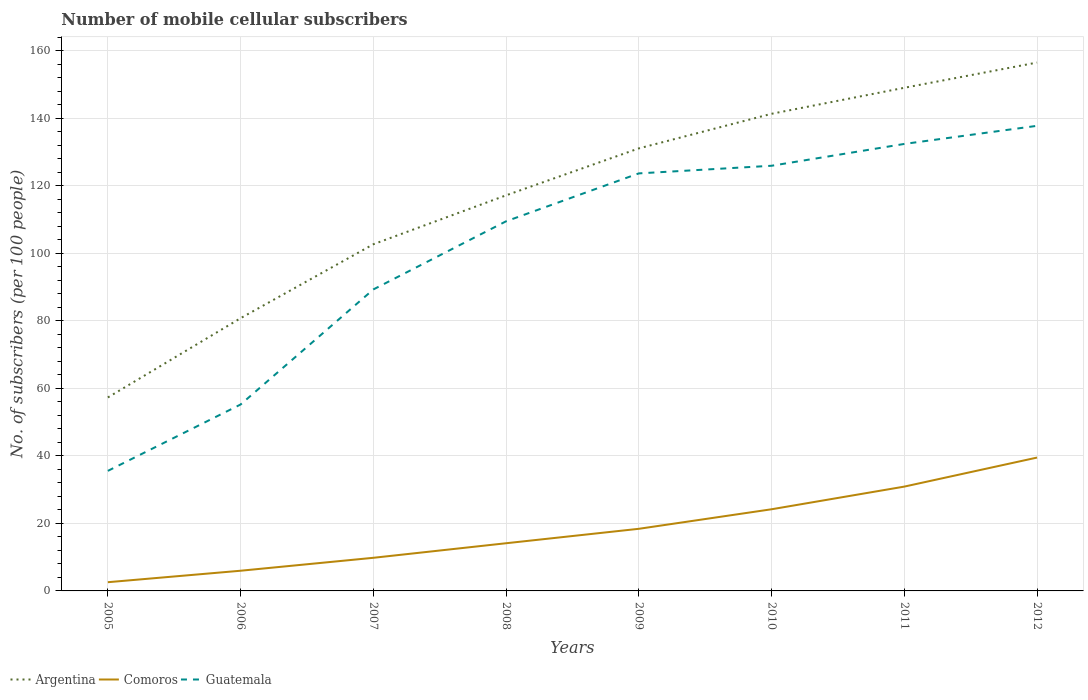Across all years, what is the maximum number of mobile cellular subscribers in Comoros?
Keep it short and to the point. 2.58. What is the total number of mobile cellular subscribers in Comoros in the graph?
Your response must be concise. -16.78. What is the difference between the highest and the second highest number of mobile cellular subscribers in Guatemala?
Keep it short and to the point. 102.25. What is the difference between the highest and the lowest number of mobile cellular subscribers in Guatemala?
Offer a terse response. 5. How many lines are there?
Your response must be concise. 3. How many years are there in the graph?
Offer a very short reply. 8. What is the difference between two consecutive major ticks on the Y-axis?
Provide a succinct answer. 20. Are the values on the major ticks of Y-axis written in scientific E-notation?
Keep it short and to the point. No. Where does the legend appear in the graph?
Offer a very short reply. Bottom left. What is the title of the graph?
Give a very brief answer. Number of mobile cellular subscribers. Does "Venezuela" appear as one of the legend labels in the graph?
Your response must be concise. No. What is the label or title of the X-axis?
Make the answer very short. Years. What is the label or title of the Y-axis?
Ensure brevity in your answer.  No. of subscribers (per 100 people). What is the No. of subscribers (per 100 people) of Argentina in 2005?
Keep it short and to the point. 57.33. What is the No. of subscribers (per 100 people) in Comoros in 2005?
Offer a terse response. 2.58. What is the No. of subscribers (per 100 people) of Guatemala in 2005?
Your answer should be compact. 35.57. What is the No. of subscribers (per 100 people) of Argentina in 2006?
Provide a short and direct response. 80.82. What is the No. of subscribers (per 100 people) in Comoros in 2006?
Provide a short and direct response. 5.98. What is the No. of subscribers (per 100 people) of Guatemala in 2006?
Provide a short and direct response. 55.24. What is the No. of subscribers (per 100 people) in Argentina in 2007?
Provide a short and direct response. 102.72. What is the No. of subscribers (per 100 people) of Comoros in 2007?
Give a very brief answer. 9.82. What is the No. of subscribers (per 100 people) in Guatemala in 2007?
Give a very brief answer. 89.33. What is the No. of subscribers (per 100 people) in Argentina in 2008?
Your answer should be compact. 117.22. What is the No. of subscribers (per 100 people) in Comoros in 2008?
Your answer should be very brief. 14.13. What is the No. of subscribers (per 100 people) in Guatemala in 2008?
Keep it short and to the point. 109.53. What is the No. of subscribers (per 100 people) of Argentina in 2009?
Offer a very short reply. 131.13. What is the No. of subscribers (per 100 people) of Comoros in 2009?
Offer a very short reply. 18.41. What is the No. of subscribers (per 100 people) of Guatemala in 2009?
Offer a terse response. 123.72. What is the No. of subscribers (per 100 people) in Argentina in 2010?
Keep it short and to the point. 141.38. What is the No. of subscribers (per 100 people) of Comoros in 2010?
Give a very brief answer. 24.2. What is the No. of subscribers (per 100 people) of Guatemala in 2010?
Ensure brevity in your answer.  125.98. What is the No. of subscribers (per 100 people) of Argentina in 2011?
Provide a short and direct response. 149.09. What is the No. of subscribers (per 100 people) in Comoros in 2011?
Offer a terse response. 30.91. What is the No. of subscribers (per 100 people) of Guatemala in 2011?
Provide a succinct answer. 132.45. What is the No. of subscribers (per 100 people) in Argentina in 2012?
Your answer should be very brief. 156.56. What is the No. of subscribers (per 100 people) of Comoros in 2012?
Provide a short and direct response. 39.51. What is the No. of subscribers (per 100 people) of Guatemala in 2012?
Make the answer very short. 137.82. Across all years, what is the maximum No. of subscribers (per 100 people) in Argentina?
Make the answer very short. 156.56. Across all years, what is the maximum No. of subscribers (per 100 people) in Comoros?
Your answer should be very brief. 39.51. Across all years, what is the maximum No. of subscribers (per 100 people) in Guatemala?
Provide a short and direct response. 137.82. Across all years, what is the minimum No. of subscribers (per 100 people) in Argentina?
Your answer should be very brief. 57.33. Across all years, what is the minimum No. of subscribers (per 100 people) of Comoros?
Provide a short and direct response. 2.58. Across all years, what is the minimum No. of subscribers (per 100 people) of Guatemala?
Ensure brevity in your answer.  35.57. What is the total No. of subscribers (per 100 people) in Argentina in the graph?
Give a very brief answer. 936.26. What is the total No. of subscribers (per 100 people) in Comoros in the graph?
Ensure brevity in your answer.  145.53. What is the total No. of subscribers (per 100 people) in Guatemala in the graph?
Your response must be concise. 809.65. What is the difference between the No. of subscribers (per 100 people) of Argentina in 2005 and that in 2006?
Make the answer very short. -23.49. What is the difference between the No. of subscribers (per 100 people) of Comoros in 2005 and that in 2006?
Your answer should be compact. -3.4. What is the difference between the No. of subscribers (per 100 people) of Guatemala in 2005 and that in 2006?
Your answer should be compact. -19.67. What is the difference between the No. of subscribers (per 100 people) in Argentina in 2005 and that in 2007?
Offer a terse response. -45.39. What is the difference between the No. of subscribers (per 100 people) of Comoros in 2005 and that in 2007?
Give a very brief answer. -7.23. What is the difference between the No. of subscribers (per 100 people) in Guatemala in 2005 and that in 2007?
Provide a short and direct response. -53.76. What is the difference between the No. of subscribers (per 100 people) of Argentina in 2005 and that in 2008?
Your answer should be compact. -59.89. What is the difference between the No. of subscribers (per 100 people) in Comoros in 2005 and that in 2008?
Give a very brief answer. -11.55. What is the difference between the No. of subscribers (per 100 people) in Guatemala in 2005 and that in 2008?
Ensure brevity in your answer.  -73.96. What is the difference between the No. of subscribers (per 100 people) in Argentina in 2005 and that in 2009?
Your response must be concise. -73.8. What is the difference between the No. of subscribers (per 100 people) of Comoros in 2005 and that in 2009?
Your answer should be very brief. -15.82. What is the difference between the No. of subscribers (per 100 people) of Guatemala in 2005 and that in 2009?
Make the answer very short. -88.15. What is the difference between the No. of subscribers (per 100 people) of Argentina in 2005 and that in 2010?
Your response must be concise. -84.05. What is the difference between the No. of subscribers (per 100 people) of Comoros in 2005 and that in 2010?
Give a very brief answer. -21.61. What is the difference between the No. of subscribers (per 100 people) of Guatemala in 2005 and that in 2010?
Your answer should be very brief. -90.41. What is the difference between the No. of subscribers (per 100 people) in Argentina in 2005 and that in 2011?
Give a very brief answer. -91.76. What is the difference between the No. of subscribers (per 100 people) of Comoros in 2005 and that in 2011?
Your answer should be compact. -28.33. What is the difference between the No. of subscribers (per 100 people) in Guatemala in 2005 and that in 2011?
Give a very brief answer. -96.88. What is the difference between the No. of subscribers (per 100 people) of Argentina in 2005 and that in 2012?
Your response must be concise. -99.24. What is the difference between the No. of subscribers (per 100 people) of Comoros in 2005 and that in 2012?
Your answer should be compact. -36.93. What is the difference between the No. of subscribers (per 100 people) of Guatemala in 2005 and that in 2012?
Give a very brief answer. -102.25. What is the difference between the No. of subscribers (per 100 people) of Argentina in 2006 and that in 2007?
Provide a short and direct response. -21.9. What is the difference between the No. of subscribers (per 100 people) of Comoros in 2006 and that in 2007?
Make the answer very short. -3.83. What is the difference between the No. of subscribers (per 100 people) of Guatemala in 2006 and that in 2007?
Your answer should be very brief. -34.09. What is the difference between the No. of subscribers (per 100 people) in Argentina in 2006 and that in 2008?
Offer a very short reply. -36.4. What is the difference between the No. of subscribers (per 100 people) of Comoros in 2006 and that in 2008?
Your response must be concise. -8.15. What is the difference between the No. of subscribers (per 100 people) in Guatemala in 2006 and that in 2008?
Your answer should be compact. -54.29. What is the difference between the No. of subscribers (per 100 people) in Argentina in 2006 and that in 2009?
Make the answer very short. -50.31. What is the difference between the No. of subscribers (per 100 people) of Comoros in 2006 and that in 2009?
Provide a short and direct response. -12.42. What is the difference between the No. of subscribers (per 100 people) in Guatemala in 2006 and that in 2009?
Provide a short and direct response. -68.48. What is the difference between the No. of subscribers (per 100 people) in Argentina in 2006 and that in 2010?
Give a very brief answer. -60.56. What is the difference between the No. of subscribers (per 100 people) of Comoros in 2006 and that in 2010?
Your response must be concise. -18.21. What is the difference between the No. of subscribers (per 100 people) in Guatemala in 2006 and that in 2010?
Your response must be concise. -70.74. What is the difference between the No. of subscribers (per 100 people) of Argentina in 2006 and that in 2011?
Keep it short and to the point. -68.27. What is the difference between the No. of subscribers (per 100 people) of Comoros in 2006 and that in 2011?
Your answer should be very brief. -24.93. What is the difference between the No. of subscribers (per 100 people) of Guatemala in 2006 and that in 2011?
Your answer should be compact. -77.21. What is the difference between the No. of subscribers (per 100 people) of Argentina in 2006 and that in 2012?
Provide a short and direct response. -75.75. What is the difference between the No. of subscribers (per 100 people) in Comoros in 2006 and that in 2012?
Your answer should be very brief. -33.53. What is the difference between the No. of subscribers (per 100 people) in Guatemala in 2006 and that in 2012?
Keep it short and to the point. -82.58. What is the difference between the No. of subscribers (per 100 people) of Argentina in 2007 and that in 2008?
Offer a very short reply. -14.5. What is the difference between the No. of subscribers (per 100 people) in Comoros in 2007 and that in 2008?
Make the answer very short. -4.31. What is the difference between the No. of subscribers (per 100 people) in Guatemala in 2007 and that in 2008?
Your response must be concise. -20.19. What is the difference between the No. of subscribers (per 100 people) of Argentina in 2007 and that in 2009?
Provide a succinct answer. -28.41. What is the difference between the No. of subscribers (per 100 people) of Comoros in 2007 and that in 2009?
Provide a short and direct response. -8.59. What is the difference between the No. of subscribers (per 100 people) in Guatemala in 2007 and that in 2009?
Your answer should be very brief. -34.39. What is the difference between the No. of subscribers (per 100 people) in Argentina in 2007 and that in 2010?
Make the answer very short. -38.66. What is the difference between the No. of subscribers (per 100 people) in Comoros in 2007 and that in 2010?
Offer a terse response. -14.38. What is the difference between the No. of subscribers (per 100 people) in Guatemala in 2007 and that in 2010?
Your answer should be compact. -36.65. What is the difference between the No. of subscribers (per 100 people) in Argentina in 2007 and that in 2011?
Make the answer very short. -46.37. What is the difference between the No. of subscribers (per 100 people) of Comoros in 2007 and that in 2011?
Offer a terse response. -21.09. What is the difference between the No. of subscribers (per 100 people) of Guatemala in 2007 and that in 2011?
Your response must be concise. -43.12. What is the difference between the No. of subscribers (per 100 people) of Argentina in 2007 and that in 2012?
Ensure brevity in your answer.  -53.84. What is the difference between the No. of subscribers (per 100 people) in Comoros in 2007 and that in 2012?
Offer a terse response. -29.7. What is the difference between the No. of subscribers (per 100 people) in Guatemala in 2007 and that in 2012?
Ensure brevity in your answer.  -48.48. What is the difference between the No. of subscribers (per 100 people) of Argentina in 2008 and that in 2009?
Provide a succinct answer. -13.91. What is the difference between the No. of subscribers (per 100 people) of Comoros in 2008 and that in 2009?
Offer a terse response. -4.28. What is the difference between the No. of subscribers (per 100 people) of Guatemala in 2008 and that in 2009?
Keep it short and to the point. -14.19. What is the difference between the No. of subscribers (per 100 people) in Argentina in 2008 and that in 2010?
Your answer should be very brief. -24.16. What is the difference between the No. of subscribers (per 100 people) of Comoros in 2008 and that in 2010?
Provide a short and direct response. -10.07. What is the difference between the No. of subscribers (per 100 people) in Guatemala in 2008 and that in 2010?
Ensure brevity in your answer.  -16.46. What is the difference between the No. of subscribers (per 100 people) of Argentina in 2008 and that in 2011?
Your answer should be very brief. -31.87. What is the difference between the No. of subscribers (per 100 people) in Comoros in 2008 and that in 2011?
Make the answer very short. -16.78. What is the difference between the No. of subscribers (per 100 people) in Guatemala in 2008 and that in 2011?
Offer a terse response. -22.92. What is the difference between the No. of subscribers (per 100 people) of Argentina in 2008 and that in 2012?
Your answer should be very brief. -39.34. What is the difference between the No. of subscribers (per 100 people) of Comoros in 2008 and that in 2012?
Your answer should be very brief. -25.38. What is the difference between the No. of subscribers (per 100 people) in Guatemala in 2008 and that in 2012?
Give a very brief answer. -28.29. What is the difference between the No. of subscribers (per 100 people) of Argentina in 2009 and that in 2010?
Keep it short and to the point. -10.25. What is the difference between the No. of subscribers (per 100 people) in Comoros in 2009 and that in 2010?
Provide a succinct answer. -5.79. What is the difference between the No. of subscribers (per 100 people) in Guatemala in 2009 and that in 2010?
Your answer should be compact. -2.26. What is the difference between the No. of subscribers (per 100 people) of Argentina in 2009 and that in 2011?
Provide a succinct answer. -17.96. What is the difference between the No. of subscribers (per 100 people) of Comoros in 2009 and that in 2011?
Your answer should be very brief. -12.51. What is the difference between the No. of subscribers (per 100 people) of Guatemala in 2009 and that in 2011?
Offer a very short reply. -8.73. What is the difference between the No. of subscribers (per 100 people) of Argentina in 2009 and that in 2012?
Make the answer very short. -25.44. What is the difference between the No. of subscribers (per 100 people) of Comoros in 2009 and that in 2012?
Provide a succinct answer. -21.11. What is the difference between the No. of subscribers (per 100 people) of Guatemala in 2009 and that in 2012?
Your answer should be compact. -14.1. What is the difference between the No. of subscribers (per 100 people) in Argentina in 2010 and that in 2011?
Your response must be concise. -7.71. What is the difference between the No. of subscribers (per 100 people) in Comoros in 2010 and that in 2011?
Provide a short and direct response. -6.71. What is the difference between the No. of subscribers (per 100 people) of Guatemala in 2010 and that in 2011?
Provide a short and direct response. -6.47. What is the difference between the No. of subscribers (per 100 people) in Argentina in 2010 and that in 2012?
Provide a short and direct response. -15.18. What is the difference between the No. of subscribers (per 100 people) of Comoros in 2010 and that in 2012?
Your answer should be very brief. -15.32. What is the difference between the No. of subscribers (per 100 people) of Guatemala in 2010 and that in 2012?
Ensure brevity in your answer.  -11.84. What is the difference between the No. of subscribers (per 100 people) in Argentina in 2011 and that in 2012?
Provide a short and direct response. -7.47. What is the difference between the No. of subscribers (per 100 people) in Comoros in 2011 and that in 2012?
Your answer should be very brief. -8.6. What is the difference between the No. of subscribers (per 100 people) of Guatemala in 2011 and that in 2012?
Provide a succinct answer. -5.37. What is the difference between the No. of subscribers (per 100 people) of Argentina in 2005 and the No. of subscribers (per 100 people) of Comoros in 2006?
Make the answer very short. 51.35. What is the difference between the No. of subscribers (per 100 people) in Argentina in 2005 and the No. of subscribers (per 100 people) in Guatemala in 2006?
Your response must be concise. 2.09. What is the difference between the No. of subscribers (per 100 people) of Comoros in 2005 and the No. of subscribers (per 100 people) of Guatemala in 2006?
Provide a short and direct response. -52.66. What is the difference between the No. of subscribers (per 100 people) in Argentina in 2005 and the No. of subscribers (per 100 people) in Comoros in 2007?
Offer a very short reply. 47.51. What is the difference between the No. of subscribers (per 100 people) in Argentina in 2005 and the No. of subscribers (per 100 people) in Guatemala in 2007?
Give a very brief answer. -32.01. What is the difference between the No. of subscribers (per 100 people) in Comoros in 2005 and the No. of subscribers (per 100 people) in Guatemala in 2007?
Provide a succinct answer. -86.75. What is the difference between the No. of subscribers (per 100 people) in Argentina in 2005 and the No. of subscribers (per 100 people) in Comoros in 2008?
Provide a succinct answer. 43.2. What is the difference between the No. of subscribers (per 100 people) in Argentina in 2005 and the No. of subscribers (per 100 people) in Guatemala in 2008?
Offer a terse response. -52.2. What is the difference between the No. of subscribers (per 100 people) of Comoros in 2005 and the No. of subscribers (per 100 people) of Guatemala in 2008?
Your answer should be compact. -106.94. What is the difference between the No. of subscribers (per 100 people) of Argentina in 2005 and the No. of subscribers (per 100 people) of Comoros in 2009?
Make the answer very short. 38.92. What is the difference between the No. of subscribers (per 100 people) in Argentina in 2005 and the No. of subscribers (per 100 people) in Guatemala in 2009?
Provide a short and direct response. -66.39. What is the difference between the No. of subscribers (per 100 people) in Comoros in 2005 and the No. of subscribers (per 100 people) in Guatemala in 2009?
Provide a succinct answer. -121.14. What is the difference between the No. of subscribers (per 100 people) of Argentina in 2005 and the No. of subscribers (per 100 people) of Comoros in 2010?
Your answer should be compact. 33.13. What is the difference between the No. of subscribers (per 100 people) in Argentina in 2005 and the No. of subscribers (per 100 people) in Guatemala in 2010?
Give a very brief answer. -68.65. What is the difference between the No. of subscribers (per 100 people) in Comoros in 2005 and the No. of subscribers (per 100 people) in Guatemala in 2010?
Provide a short and direct response. -123.4. What is the difference between the No. of subscribers (per 100 people) in Argentina in 2005 and the No. of subscribers (per 100 people) in Comoros in 2011?
Keep it short and to the point. 26.42. What is the difference between the No. of subscribers (per 100 people) of Argentina in 2005 and the No. of subscribers (per 100 people) of Guatemala in 2011?
Your answer should be very brief. -75.12. What is the difference between the No. of subscribers (per 100 people) in Comoros in 2005 and the No. of subscribers (per 100 people) in Guatemala in 2011?
Offer a very short reply. -129.87. What is the difference between the No. of subscribers (per 100 people) of Argentina in 2005 and the No. of subscribers (per 100 people) of Comoros in 2012?
Make the answer very short. 17.82. What is the difference between the No. of subscribers (per 100 people) of Argentina in 2005 and the No. of subscribers (per 100 people) of Guatemala in 2012?
Give a very brief answer. -80.49. What is the difference between the No. of subscribers (per 100 people) of Comoros in 2005 and the No. of subscribers (per 100 people) of Guatemala in 2012?
Provide a succinct answer. -135.24. What is the difference between the No. of subscribers (per 100 people) in Argentina in 2006 and the No. of subscribers (per 100 people) in Comoros in 2007?
Provide a succinct answer. 71. What is the difference between the No. of subscribers (per 100 people) in Argentina in 2006 and the No. of subscribers (per 100 people) in Guatemala in 2007?
Provide a succinct answer. -8.52. What is the difference between the No. of subscribers (per 100 people) of Comoros in 2006 and the No. of subscribers (per 100 people) of Guatemala in 2007?
Your answer should be compact. -83.35. What is the difference between the No. of subscribers (per 100 people) in Argentina in 2006 and the No. of subscribers (per 100 people) in Comoros in 2008?
Make the answer very short. 66.69. What is the difference between the No. of subscribers (per 100 people) of Argentina in 2006 and the No. of subscribers (per 100 people) of Guatemala in 2008?
Provide a short and direct response. -28.71. What is the difference between the No. of subscribers (per 100 people) in Comoros in 2006 and the No. of subscribers (per 100 people) in Guatemala in 2008?
Your response must be concise. -103.55. What is the difference between the No. of subscribers (per 100 people) in Argentina in 2006 and the No. of subscribers (per 100 people) in Comoros in 2009?
Your answer should be very brief. 62.41. What is the difference between the No. of subscribers (per 100 people) in Argentina in 2006 and the No. of subscribers (per 100 people) in Guatemala in 2009?
Provide a short and direct response. -42.9. What is the difference between the No. of subscribers (per 100 people) of Comoros in 2006 and the No. of subscribers (per 100 people) of Guatemala in 2009?
Your response must be concise. -117.74. What is the difference between the No. of subscribers (per 100 people) in Argentina in 2006 and the No. of subscribers (per 100 people) in Comoros in 2010?
Your response must be concise. 56.62. What is the difference between the No. of subscribers (per 100 people) of Argentina in 2006 and the No. of subscribers (per 100 people) of Guatemala in 2010?
Provide a short and direct response. -45.16. What is the difference between the No. of subscribers (per 100 people) of Comoros in 2006 and the No. of subscribers (per 100 people) of Guatemala in 2010?
Ensure brevity in your answer.  -120. What is the difference between the No. of subscribers (per 100 people) of Argentina in 2006 and the No. of subscribers (per 100 people) of Comoros in 2011?
Offer a terse response. 49.91. What is the difference between the No. of subscribers (per 100 people) in Argentina in 2006 and the No. of subscribers (per 100 people) in Guatemala in 2011?
Offer a very short reply. -51.63. What is the difference between the No. of subscribers (per 100 people) in Comoros in 2006 and the No. of subscribers (per 100 people) in Guatemala in 2011?
Offer a very short reply. -126.47. What is the difference between the No. of subscribers (per 100 people) in Argentina in 2006 and the No. of subscribers (per 100 people) in Comoros in 2012?
Offer a terse response. 41.31. What is the difference between the No. of subscribers (per 100 people) of Argentina in 2006 and the No. of subscribers (per 100 people) of Guatemala in 2012?
Provide a succinct answer. -57. What is the difference between the No. of subscribers (per 100 people) of Comoros in 2006 and the No. of subscribers (per 100 people) of Guatemala in 2012?
Keep it short and to the point. -131.84. What is the difference between the No. of subscribers (per 100 people) in Argentina in 2007 and the No. of subscribers (per 100 people) in Comoros in 2008?
Offer a very short reply. 88.59. What is the difference between the No. of subscribers (per 100 people) in Argentina in 2007 and the No. of subscribers (per 100 people) in Guatemala in 2008?
Provide a succinct answer. -6.81. What is the difference between the No. of subscribers (per 100 people) in Comoros in 2007 and the No. of subscribers (per 100 people) in Guatemala in 2008?
Offer a terse response. -99.71. What is the difference between the No. of subscribers (per 100 people) of Argentina in 2007 and the No. of subscribers (per 100 people) of Comoros in 2009?
Keep it short and to the point. 84.32. What is the difference between the No. of subscribers (per 100 people) in Argentina in 2007 and the No. of subscribers (per 100 people) in Guatemala in 2009?
Keep it short and to the point. -21. What is the difference between the No. of subscribers (per 100 people) in Comoros in 2007 and the No. of subscribers (per 100 people) in Guatemala in 2009?
Provide a short and direct response. -113.91. What is the difference between the No. of subscribers (per 100 people) in Argentina in 2007 and the No. of subscribers (per 100 people) in Comoros in 2010?
Ensure brevity in your answer.  78.53. What is the difference between the No. of subscribers (per 100 people) of Argentina in 2007 and the No. of subscribers (per 100 people) of Guatemala in 2010?
Your answer should be compact. -23.26. What is the difference between the No. of subscribers (per 100 people) in Comoros in 2007 and the No. of subscribers (per 100 people) in Guatemala in 2010?
Your response must be concise. -116.17. What is the difference between the No. of subscribers (per 100 people) in Argentina in 2007 and the No. of subscribers (per 100 people) in Comoros in 2011?
Your answer should be very brief. 71.81. What is the difference between the No. of subscribers (per 100 people) in Argentina in 2007 and the No. of subscribers (per 100 people) in Guatemala in 2011?
Keep it short and to the point. -29.73. What is the difference between the No. of subscribers (per 100 people) of Comoros in 2007 and the No. of subscribers (per 100 people) of Guatemala in 2011?
Provide a short and direct response. -122.64. What is the difference between the No. of subscribers (per 100 people) of Argentina in 2007 and the No. of subscribers (per 100 people) of Comoros in 2012?
Your answer should be very brief. 63.21. What is the difference between the No. of subscribers (per 100 people) of Argentina in 2007 and the No. of subscribers (per 100 people) of Guatemala in 2012?
Provide a succinct answer. -35.1. What is the difference between the No. of subscribers (per 100 people) in Comoros in 2007 and the No. of subscribers (per 100 people) in Guatemala in 2012?
Your response must be concise. -128. What is the difference between the No. of subscribers (per 100 people) in Argentina in 2008 and the No. of subscribers (per 100 people) in Comoros in 2009?
Provide a short and direct response. 98.82. What is the difference between the No. of subscribers (per 100 people) of Argentina in 2008 and the No. of subscribers (per 100 people) of Guatemala in 2009?
Give a very brief answer. -6.5. What is the difference between the No. of subscribers (per 100 people) in Comoros in 2008 and the No. of subscribers (per 100 people) in Guatemala in 2009?
Ensure brevity in your answer.  -109.59. What is the difference between the No. of subscribers (per 100 people) in Argentina in 2008 and the No. of subscribers (per 100 people) in Comoros in 2010?
Make the answer very short. 93.03. What is the difference between the No. of subscribers (per 100 people) of Argentina in 2008 and the No. of subscribers (per 100 people) of Guatemala in 2010?
Ensure brevity in your answer.  -8.76. What is the difference between the No. of subscribers (per 100 people) in Comoros in 2008 and the No. of subscribers (per 100 people) in Guatemala in 2010?
Make the answer very short. -111.85. What is the difference between the No. of subscribers (per 100 people) of Argentina in 2008 and the No. of subscribers (per 100 people) of Comoros in 2011?
Keep it short and to the point. 86.31. What is the difference between the No. of subscribers (per 100 people) of Argentina in 2008 and the No. of subscribers (per 100 people) of Guatemala in 2011?
Keep it short and to the point. -15.23. What is the difference between the No. of subscribers (per 100 people) of Comoros in 2008 and the No. of subscribers (per 100 people) of Guatemala in 2011?
Your answer should be compact. -118.32. What is the difference between the No. of subscribers (per 100 people) of Argentina in 2008 and the No. of subscribers (per 100 people) of Comoros in 2012?
Make the answer very short. 77.71. What is the difference between the No. of subscribers (per 100 people) in Argentina in 2008 and the No. of subscribers (per 100 people) in Guatemala in 2012?
Your response must be concise. -20.6. What is the difference between the No. of subscribers (per 100 people) of Comoros in 2008 and the No. of subscribers (per 100 people) of Guatemala in 2012?
Keep it short and to the point. -123.69. What is the difference between the No. of subscribers (per 100 people) in Argentina in 2009 and the No. of subscribers (per 100 people) in Comoros in 2010?
Your response must be concise. 106.93. What is the difference between the No. of subscribers (per 100 people) in Argentina in 2009 and the No. of subscribers (per 100 people) in Guatemala in 2010?
Your response must be concise. 5.15. What is the difference between the No. of subscribers (per 100 people) in Comoros in 2009 and the No. of subscribers (per 100 people) in Guatemala in 2010?
Offer a very short reply. -107.58. What is the difference between the No. of subscribers (per 100 people) of Argentina in 2009 and the No. of subscribers (per 100 people) of Comoros in 2011?
Make the answer very short. 100.22. What is the difference between the No. of subscribers (per 100 people) in Argentina in 2009 and the No. of subscribers (per 100 people) in Guatemala in 2011?
Your answer should be compact. -1.32. What is the difference between the No. of subscribers (per 100 people) in Comoros in 2009 and the No. of subscribers (per 100 people) in Guatemala in 2011?
Provide a short and direct response. -114.05. What is the difference between the No. of subscribers (per 100 people) in Argentina in 2009 and the No. of subscribers (per 100 people) in Comoros in 2012?
Give a very brief answer. 91.62. What is the difference between the No. of subscribers (per 100 people) in Argentina in 2009 and the No. of subscribers (per 100 people) in Guatemala in 2012?
Your response must be concise. -6.69. What is the difference between the No. of subscribers (per 100 people) of Comoros in 2009 and the No. of subscribers (per 100 people) of Guatemala in 2012?
Provide a succinct answer. -119.41. What is the difference between the No. of subscribers (per 100 people) of Argentina in 2010 and the No. of subscribers (per 100 people) of Comoros in 2011?
Your answer should be very brief. 110.47. What is the difference between the No. of subscribers (per 100 people) of Argentina in 2010 and the No. of subscribers (per 100 people) of Guatemala in 2011?
Provide a short and direct response. 8.93. What is the difference between the No. of subscribers (per 100 people) in Comoros in 2010 and the No. of subscribers (per 100 people) in Guatemala in 2011?
Offer a terse response. -108.26. What is the difference between the No. of subscribers (per 100 people) of Argentina in 2010 and the No. of subscribers (per 100 people) of Comoros in 2012?
Offer a terse response. 101.87. What is the difference between the No. of subscribers (per 100 people) of Argentina in 2010 and the No. of subscribers (per 100 people) of Guatemala in 2012?
Give a very brief answer. 3.56. What is the difference between the No. of subscribers (per 100 people) in Comoros in 2010 and the No. of subscribers (per 100 people) in Guatemala in 2012?
Ensure brevity in your answer.  -113.62. What is the difference between the No. of subscribers (per 100 people) in Argentina in 2011 and the No. of subscribers (per 100 people) in Comoros in 2012?
Give a very brief answer. 109.58. What is the difference between the No. of subscribers (per 100 people) in Argentina in 2011 and the No. of subscribers (per 100 people) in Guatemala in 2012?
Your answer should be compact. 11.27. What is the difference between the No. of subscribers (per 100 people) in Comoros in 2011 and the No. of subscribers (per 100 people) in Guatemala in 2012?
Give a very brief answer. -106.91. What is the average No. of subscribers (per 100 people) of Argentina per year?
Keep it short and to the point. 117.03. What is the average No. of subscribers (per 100 people) in Comoros per year?
Provide a short and direct response. 18.19. What is the average No. of subscribers (per 100 people) in Guatemala per year?
Provide a short and direct response. 101.21. In the year 2005, what is the difference between the No. of subscribers (per 100 people) of Argentina and No. of subscribers (per 100 people) of Comoros?
Give a very brief answer. 54.74. In the year 2005, what is the difference between the No. of subscribers (per 100 people) in Argentina and No. of subscribers (per 100 people) in Guatemala?
Provide a succinct answer. 21.76. In the year 2005, what is the difference between the No. of subscribers (per 100 people) in Comoros and No. of subscribers (per 100 people) in Guatemala?
Your response must be concise. -32.99. In the year 2006, what is the difference between the No. of subscribers (per 100 people) of Argentina and No. of subscribers (per 100 people) of Comoros?
Keep it short and to the point. 74.84. In the year 2006, what is the difference between the No. of subscribers (per 100 people) in Argentina and No. of subscribers (per 100 people) in Guatemala?
Make the answer very short. 25.58. In the year 2006, what is the difference between the No. of subscribers (per 100 people) of Comoros and No. of subscribers (per 100 people) of Guatemala?
Provide a short and direct response. -49.26. In the year 2007, what is the difference between the No. of subscribers (per 100 people) of Argentina and No. of subscribers (per 100 people) of Comoros?
Give a very brief answer. 92.91. In the year 2007, what is the difference between the No. of subscribers (per 100 people) in Argentina and No. of subscribers (per 100 people) in Guatemala?
Provide a succinct answer. 13.39. In the year 2007, what is the difference between the No. of subscribers (per 100 people) of Comoros and No. of subscribers (per 100 people) of Guatemala?
Your answer should be compact. -79.52. In the year 2008, what is the difference between the No. of subscribers (per 100 people) of Argentina and No. of subscribers (per 100 people) of Comoros?
Provide a short and direct response. 103.09. In the year 2008, what is the difference between the No. of subscribers (per 100 people) of Argentina and No. of subscribers (per 100 people) of Guatemala?
Ensure brevity in your answer.  7.69. In the year 2008, what is the difference between the No. of subscribers (per 100 people) in Comoros and No. of subscribers (per 100 people) in Guatemala?
Give a very brief answer. -95.4. In the year 2009, what is the difference between the No. of subscribers (per 100 people) in Argentina and No. of subscribers (per 100 people) in Comoros?
Keep it short and to the point. 112.72. In the year 2009, what is the difference between the No. of subscribers (per 100 people) in Argentina and No. of subscribers (per 100 people) in Guatemala?
Your answer should be compact. 7.41. In the year 2009, what is the difference between the No. of subscribers (per 100 people) in Comoros and No. of subscribers (per 100 people) in Guatemala?
Ensure brevity in your answer.  -105.32. In the year 2010, what is the difference between the No. of subscribers (per 100 people) of Argentina and No. of subscribers (per 100 people) of Comoros?
Your answer should be compact. 117.19. In the year 2010, what is the difference between the No. of subscribers (per 100 people) in Argentina and No. of subscribers (per 100 people) in Guatemala?
Your answer should be compact. 15.4. In the year 2010, what is the difference between the No. of subscribers (per 100 people) of Comoros and No. of subscribers (per 100 people) of Guatemala?
Provide a short and direct response. -101.79. In the year 2011, what is the difference between the No. of subscribers (per 100 people) in Argentina and No. of subscribers (per 100 people) in Comoros?
Your answer should be compact. 118.18. In the year 2011, what is the difference between the No. of subscribers (per 100 people) in Argentina and No. of subscribers (per 100 people) in Guatemala?
Offer a terse response. 16.64. In the year 2011, what is the difference between the No. of subscribers (per 100 people) of Comoros and No. of subscribers (per 100 people) of Guatemala?
Keep it short and to the point. -101.54. In the year 2012, what is the difference between the No. of subscribers (per 100 people) of Argentina and No. of subscribers (per 100 people) of Comoros?
Offer a terse response. 117.05. In the year 2012, what is the difference between the No. of subscribers (per 100 people) in Argentina and No. of subscribers (per 100 people) in Guatemala?
Offer a very short reply. 18.75. In the year 2012, what is the difference between the No. of subscribers (per 100 people) of Comoros and No. of subscribers (per 100 people) of Guatemala?
Provide a succinct answer. -98.31. What is the ratio of the No. of subscribers (per 100 people) of Argentina in 2005 to that in 2006?
Offer a terse response. 0.71. What is the ratio of the No. of subscribers (per 100 people) of Comoros in 2005 to that in 2006?
Provide a succinct answer. 0.43. What is the ratio of the No. of subscribers (per 100 people) of Guatemala in 2005 to that in 2006?
Your answer should be very brief. 0.64. What is the ratio of the No. of subscribers (per 100 people) in Argentina in 2005 to that in 2007?
Give a very brief answer. 0.56. What is the ratio of the No. of subscribers (per 100 people) in Comoros in 2005 to that in 2007?
Your response must be concise. 0.26. What is the ratio of the No. of subscribers (per 100 people) in Guatemala in 2005 to that in 2007?
Your answer should be compact. 0.4. What is the ratio of the No. of subscribers (per 100 people) of Argentina in 2005 to that in 2008?
Your answer should be compact. 0.49. What is the ratio of the No. of subscribers (per 100 people) of Comoros in 2005 to that in 2008?
Provide a succinct answer. 0.18. What is the ratio of the No. of subscribers (per 100 people) in Guatemala in 2005 to that in 2008?
Offer a terse response. 0.32. What is the ratio of the No. of subscribers (per 100 people) in Argentina in 2005 to that in 2009?
Offer a very short reply. 0.44. What is the ratio of the No. of subscribers (per 100 people) in Comoros in 2005 to that in 2009?
Your answer should be very brief. 0.14. What is the ratio of the No. of subscribers (per 100 people) of Guatemala in 2005 to that in 2009?
Ensure brevity in your answer.  0.29. What is the ratio of the No. of subscribers (per 100 people) of Argentina in 2005 to that in 2010?
Provide a short and direct response. 0.41. What is the ratio of the No. of subscribers (per 100 people) in Comoros in 2005 to that in 2010?
Provide a succinct answer. 0.11. What is the ratio of the No. of subscribers (per 100 people) of Guatemala in 2005 to that in 2010?
Your response must be concise. 0.28. What is the ratio of the No. of subscribers (per 100 people) of Argentina in 2005 to that in 2011?
Keep it short and to the point. 0.38. What is the ratio of the No. of subscribers (per 100 people) in Comoros in 2005 to that in 2011?
Provide a succinct answer. 0.08. What is the ratio of the No. of subscribers (per 100 people) of Guatemala in 2005 to that in 2011?
Provide a short and direct response. 0.27. What is the ratio of the No. of subscribers (per 100 people) of Argentina in 2005 to that in 2012?
Provide a succinct answer. 0.37. What is the ratio of the No. of subscribers (per 100 people) of Comoros in 2005 to that in 2012?
Provide a succinct answer. 0.07. What is the ratio of the No. of subscribers (per 100 people) of Guatemala in 2005 to that in 2012?
Your answer should be very brief. 0.26. What is the ratio of the No. of subscribers (per 100 people) in Argentina in 2006 to that in 2007?
Offer a terse response. 0.79. What is the ratio of the No. of subscribers (per 100 people) in Comoros in 2006 to that in 2007?
Offer a terse response. 0.61. What is the ratio of the No. of subscribers (per 100 people) in Guatemala in 2006 to that in 2007?
Offer a very short reply. 0.62. What is the ratio of the No. of subscribers (per 100 people) in Argentina in 2006 to that in 2008?
Ensure brevity in your answer.  0.69. What is the ratio of the No. of subscribers (per 100 people) in Comoros in 2006 to that in 2008?
Your answer should be very brief. 0.42. What is the ratio of the No. of subscribers (per 100 people) in Guatemala in 2006 to that in 2008?
Your response must be concise. 0.5. What is the ratio of the No. of subscribers (per 100 people) in Argentina in 2006 to that in 2009?
Offer a terse response. 0.62. What is the ratio of the No. of subscribers (per 100 people) in Comoros in 2006 to that in 2009?
Keep it short and to the point. 0.33. What is the ratio of the No. of subscribers (per 100 people) in Guatemala in 2006 to that in 2009?
Ensure brevity in your answer.  0.45. What is the ratio of the No. of subscribers (per 100 people) in Argentina in 2006 to that in 2010?
Make the answer very short. 0.57. What is the ratio of the No. of subscribers (per 100 people) of Comoros in 2006 to that in 2010?
Offer a terse response. 0.25. What is the ratio of the No. of subscribers (per 100 people) in Guatemala in 2006 to that in 2010?
Offer a terse response. 0.44. What is the ratio of the No. of subscribers (per 100 people) in Argentina in 2006 to that in 2011?
Keep it short and to the point. 0.54. What is the ratio of the No. of subscribers (per 100 people) in Comoros in 2006 to that in 2011?
Your answer should be very brief. 0.19. What is the ratio of the No. of subscribers (per 100 people) in Guatemala in 2006 to that in 2011?
Make the answer very short. 0.42. What is the ratio of the No. of subscribers (per 100 people) in Argentina in 2006 to that in 2012?
Make the answer very short. 0.52. What is the ratio of the No. of subscribers (per 100 people) in Comoros in 2006 to that in 2012?
Ensure brevity in your answer.  0.15. What is the ratio of the No. of subscribers (per 100 people) in Guatemala in 2006 to that in 2012?
Provide a succinct answer. 0.4. What is the ratio of the No. of subscribers (per 100 people) of Argentina in 2007 to that in 2008?
Your response must be concise. 0.88. What is the ratio of the No. of subscribers (per 100 people) of Comoros in 2007 to that in 2008?
Make the answer very short. 0.69. What is the ratio of the No. of subscribers (per 100 people) of Guatemala in 2007 to that in 2008?
Your answer should be very brief. 0.82. What is the ratio of the No. of subscribers (per 100 people) in Argentina in 2007 to that in 2009?
Ensure brevity in your answer.  0.78. What is the ratio of the No. of subscribers (per 100 people) of Comoros in 2007 to that in 2009?
Keep it short and to the point. 0.53. What is the ratio of the No. of subscribers (per 100 people) in Guatemala in 2007 to that in 2009?
Offer a very short reply. 0.72. What is the ratio of the No. of subscribers (per 100 people) in Argentina in 2007 to that in 2010?
Give a very brief answer. 0.73. What is the ratio of the No. of subscribers (per 100 people) in Comoros in 2007 to that in 2010?
Provide a succinct answer. 0.41. What is the ratio of the No. of subscribers (per 100 people) in Guatemala in 2007 to that in 2010?
Provide a succinct answer. 0.71. What is the ratio of the No. of subscribers (per 100 people) of Argentina in 2007 to that in 2011?
Provide a succinct answer. 0.69. What is the ratio of the No. of subscribers (per 100 people) in Comoros in 2007 to that in 2011?
Offer a very short reply. 0.32. What is the ratio of the No. of subscribers (per 100 people) of Guatemala in 2007 to that in 2011?
Your answer should be compact. 0.67. What is the ratio of the No. of subscribers (per 100 people) in Argentina in 2007 to that in 2012?
Provide a short and direct response. 0.66. What is the ratio of the No. of subscribers (per 100 people) in Comoros in 2007 to that in 2012?
Keep it short and to the point. 0.25. What is the ratio of the No. of subscribers (per 100 people) in Guatemala in 2007 to that in 2012?
Offer a very short reply. 0.65. What is the ratio of the No. of subscribers (per 100 people) of Argentina in 2008 to that in 2009?
Keep it short and to the point. 0.89. What is the ratio of the No. of subscribers (per 100 people) in Comoros in 2008 to that in 2009?
Give a very brief answer. 0.77. What is the ratio of the No. of subscribers (per 100 people) of Guatemala in 2008 to that in 2009?
Provide a short and direct response. 0.89. What is the ratio of the No. of subscribers (per 100 people) of Argentina in 2008 to that in 2010?
Provide a succinct answer. 0.83. What is the ratio of the No. of subscribers (per 100 people) of Comoros in 2008 to that in 2010?
Your response must be concise. 0.58. What is the ratio of the No. of subscribers (per 100 people) of Guatemala in 2008 to that in 2010?
Offer a very short reply. 0.87. What is the ratio of the No. of subscribers (per 100 people) in Argentina in 2008 to that in 2011?
Your answer should be very brief. 0.79. What is the ratio of the No. of subscribers (per 100 people) of Comoros in 2008 to that in 2011?
Ensure brevity in your answer.  0.46. What is the ratio of the No. of subscribers (per 100 people) in Guatemala in 2008 to that in 2011?
Offer a very short reply. 0.83. What is the ratio of the No. of subscribers (per 100 people) of Argentina in 2008 to that in 2012?
Give a very brief answer. 0.75. What is the ratio of the No. of subscribers (per 100 people) in Comoros in 2008 to that in 2012?
Offer a very short reply. 0.36. What is the ratio of the No. of subscribers (per 100 people) in Guatemala in 2008 to that in 2012?
Keep it short and to the point. 0.79. What is the ratio of the No. of subscribers (per 100 people) of Argentina in 2009 to that in 2010?
Provide a succinct answer. 0.93. What is the ratio of the No. of subscribers (per 100 people) in Comoros in 2009 to that in 2010?
Offer a terse response. 0.76. What is the ratio of the No. of subscribers (per 100 people) in Guatemala in 2009 to that in 2010?
Keep it short and to the point. 0.98. What is the ratio of the No. of subscribers (per 100 people) in Argentina in 2009 to that in 2011?
Offer a terse response. 0.88. What is the ratio of the No. of subscribers (per 100 people) in Comoros in 2009 to that in 2011?
Keep it short and to the point. 0.6. What is the ratio of the No. of subscribers (per 100 people) of Guatemala in 2009 to that in 2011?
Your answer should be compact. 0.93. What is the ratio of the No. of subscribers (per 100 people) in Argentina in 2009 to that in 2012?
Provide a succinct answer. 0.84. What is the ratio of the No. of subscribers (per 100 people) of Comoros in 2009 to that in 2012?
Provide a short and direct response. 0.47. What is the ratio of the No. of subscribers (per 100 people) in Guatemala in 2009 to that in 2012?
Your answer should be compact. 0.9. What is the ratio of the No. of subscribers (per 100 people) in Argentina in 2010 to that in 2011?
Offer a very short reply. 0.95. What is the ratio of the No. of subscribers (per 100 people) of Comoros in 2010 to that in 2011?
Your response must be concise. 0.78. What is the ratio of the No. of subscribers (per 100 people) in Guatemala in 2010 to that in 2011?
Provide a short and direct response. 0.95. What is the ratio of the No. of subscribers (per 100 people) in Argentina in 2010 to that in 2012?
Provide a succinct answer. 0.9. What is the ratio of the No. of subscribers (per 100 people) in Comoros in 2010 to that in 2012?
Your response must be concise. 0.61. What is the ratio of the No. of subscribers (per 100 people) in Guatemala in 2010 to that in 2012?
Keep it short and to the point. 0.91. What is the ratio of the No. of subscribers (per 100 people) in Argentina in 2011 to that in 2012?
Your answer should be very brief. 0.95. What is the ratio of the No. of subscribers (per 100 people) in Comoros in 2011 to that in 2012?
Your answer should be very brief. 0.78. What is the ratio of the No. of subscribers (per 100 people) in Guatemala in 2011 to that in 2012?
Keep it short and to the point. 0.96. What is the difference between the highest and the second highest No. of subscribers (per 100 people) in Argentina?
Your response must be concise. 7.47. What is the difference between the highest and the second highest No. of subscribers (per 100 people) of Comoros?
Make the answer very short. 8.6. What is the difference between the highest and the second highest No. of subscribers (per 100 people) of Guatemala?
Provide a short and direct response. 5.37. What is the difference between the highest and the lowest No. of subscribers (per 100 people) of Argentina?
Give a very brief answer. 99.24. What is the difference between the highest and the lowest No. of subscribers (per 100 people) in Comoros?
Give a very brief answer. 36.93. What is the difference between the highest and the lowest No. of subscribers (per 100 people) of Guatemala?
Provide a succinct answer. 102.25. 